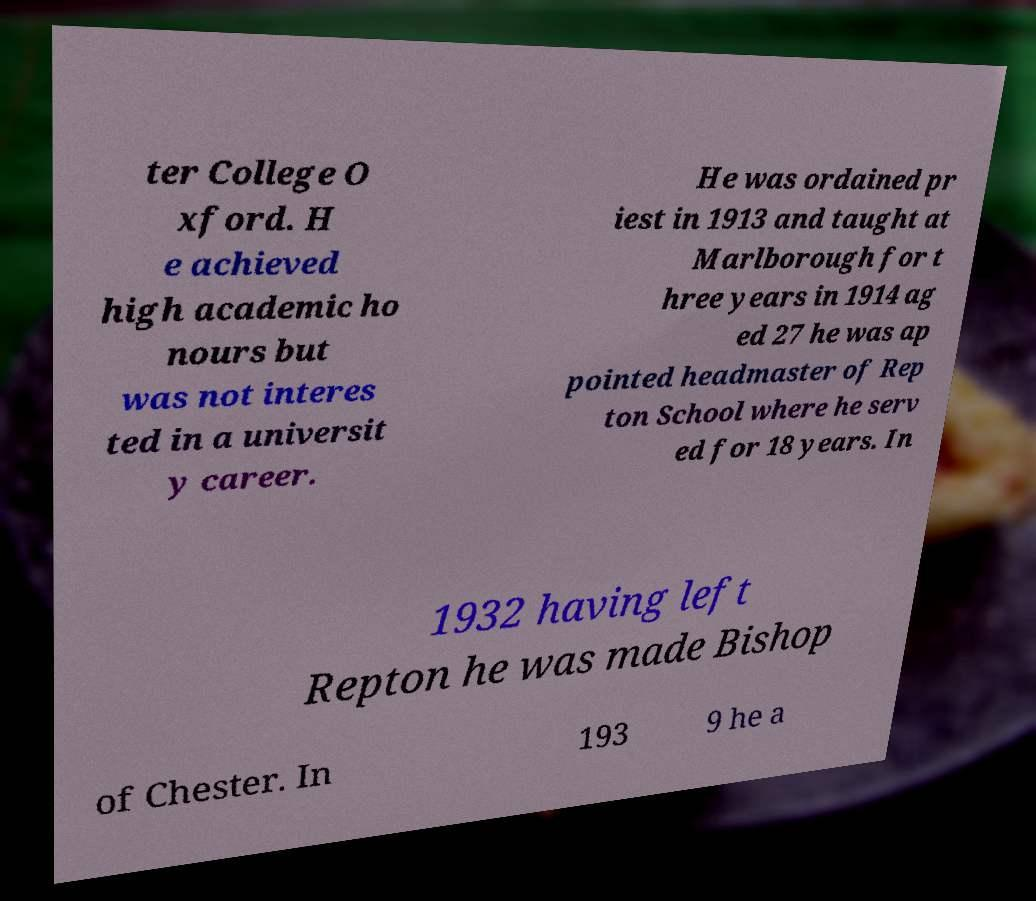What messages or text are displayed in this image? I need them in a readable, typed format. ter College O xford. H e achieved high academic ho nours but was not interes ted in a universit y career. He was ordained pr iest in 1913 and taught at Marlborough for t hree years in 1914 ag ed 27 he was ap pointed headmaster of Rep ton School where he serv ed for 18 years. In 1932 having left Repton he was made Bishop of Chester. In 193 9 he a 